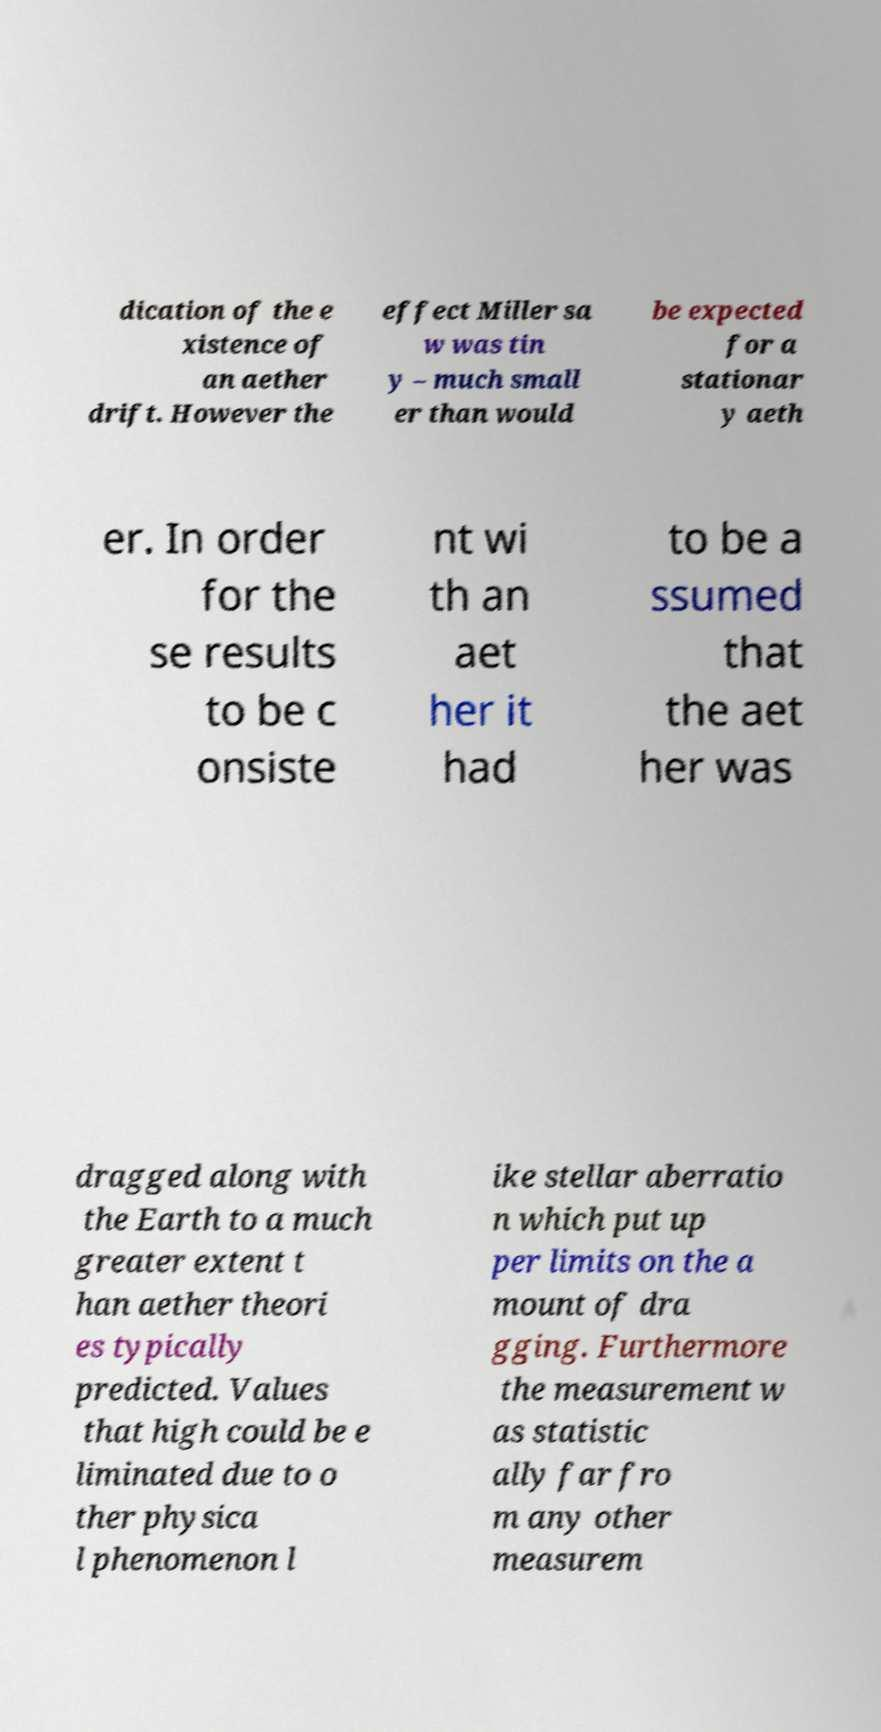Can you read and provide the text displayed in the image?This photo seems to have some interesting text. Can you extract and type it out for me? dication of the e xistence of an aether drift. However the effect Miller sa w was tin y – much small er than would be expected for a stationar y aeth er. In order for the se results to be c onsiste nt wi th an aet her it had to be a ssumed that the aet her was dragged along with the Earth to a much greater extent t han aether theori es typically predicted. Values that high could be e liminated due to o ther physica l phenomenon l ike stellar aberratio n which put up per limits on the a mount of dra gging. Furthermore the measurement w as statistic ally far fro m any other measurem 